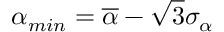Convert formula to latex. <formula><loc_0><loc_0><loc_500><loc_500>\alpha _ { \min } = \overline { \alpha } - \sqrt { 3 } \sigma _ { \alpha }</formula> 